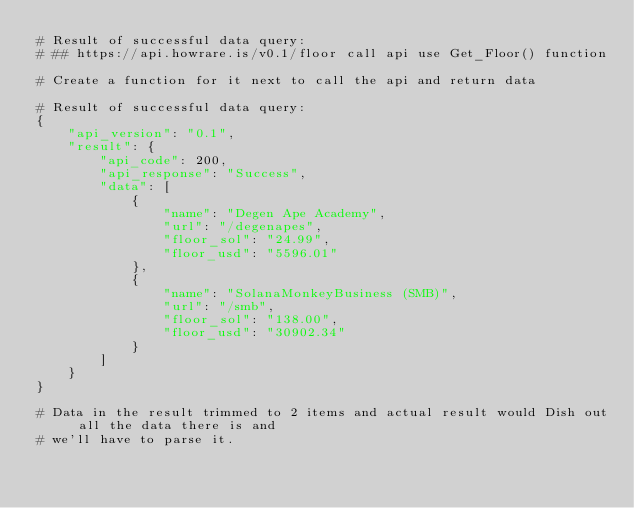Convert code to text. <code><loc_0><loc_0><loc_500><loc_500><_Python_># Result of successful data query:
# ## https://api.howrare.is/v0.1/floor call api use Get_Floor() function

# Create a function for it next to call the api and return data

# Result of successful data query:
{
    "api_version": "0.1",
    "result": {
        "api_code": 200,
        "api_response": "Success",
        "data": [
            {
                "name": "Degen Ape Academy",
                "url": "/degenapes",
                "floor_sol": "24.99",
                "floor_usd": "5596.01"
            },
            {
                "name": "SolanaMonkeyBusiness (SMB)",
                "url": "/smb",
                "floor_sol": "138.00",
                "floor_usd": "30902.34"
            }
        ]
    }
}
                    
# Data in the result trimmed to 2 items and actual result would Dish out all the data there is and 
# we'll have to parse it.
</code> 